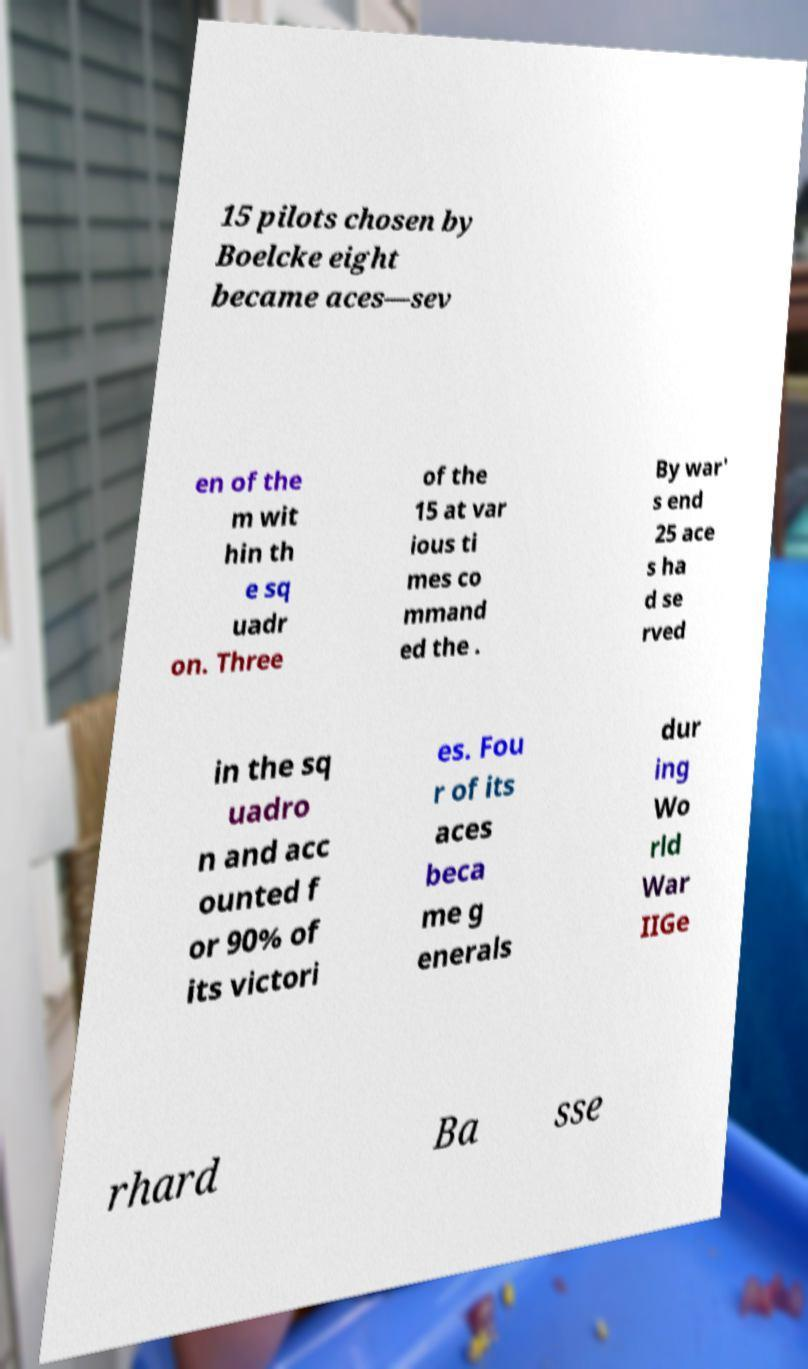What messages or text are displayed in this image? I need them in a readable, typed format. 15 pilots chosen by Boelcke eight became aces—sev en of the m wit hin th e sq uadr on. Three of the 15 at var ious ti mes co mmand ed the . By war' s end 25 ace s ha d se rved in the sq uadro n and acc ounted f or 90% of its victori es. Fou r of its aces beca me g enerals dur ing Wo rld War IIGe rhard Ba sse 